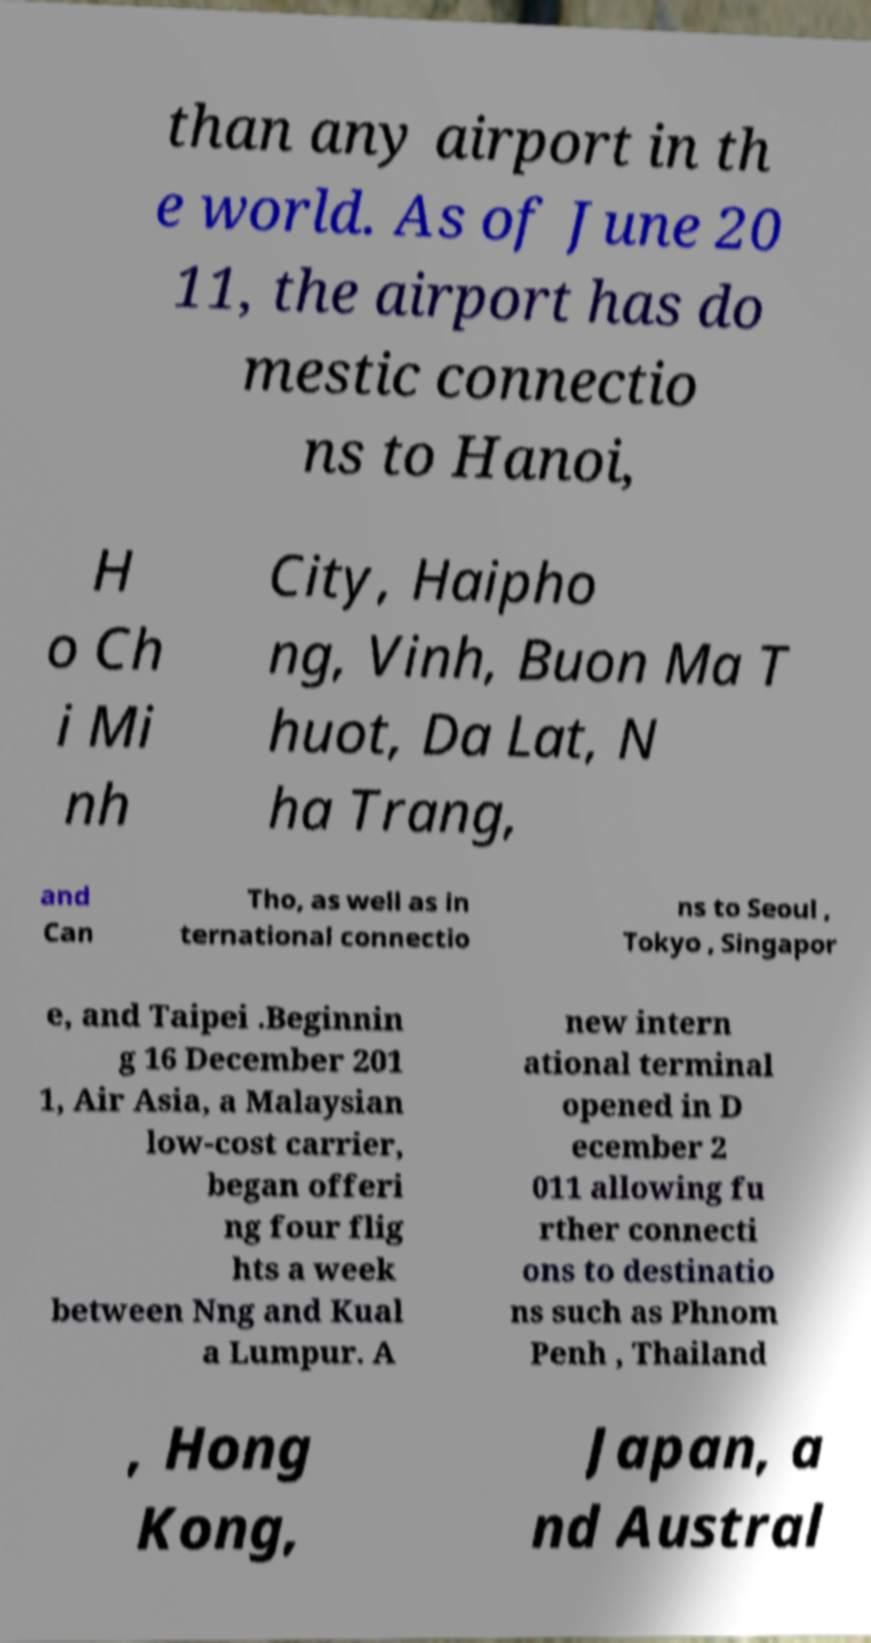Can you accurately transcribe the text from the provided image for me? than any airport in th e world. As of June 20 11, the airport has do mestic connectio ns to Hanoi, H o Ch i Mi nh City, Haipho ng, Vinh, Buon Ma T huot, Da Lat, N ha Trang, and Can Tho, as well as in ternational connectio ns to Seoul , Tokyo , Singapor e, and Taipei .Beginnin g 16 December 201 1, Air Asia, a Malaysian low-cost carrier, began offeri ng four flig hts a week between Nng and Kual a Lumpur. A new intern ational terminal opened in D ecember 2 011 allowing fu rther connecti ons to destinatio ns such as Phnom Penh , Thailand , Hong Kong, Japan, a nd Austral 